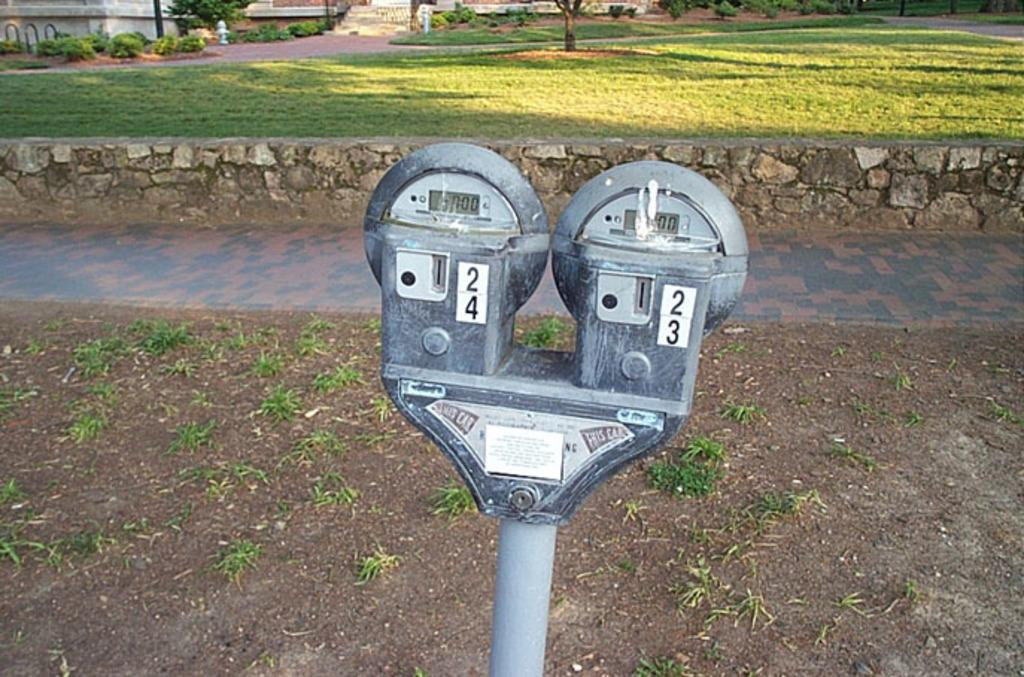<image>
Give a short and clear explanation of the subsequent image. Two parking meters side by side numbers 23 and 24. 